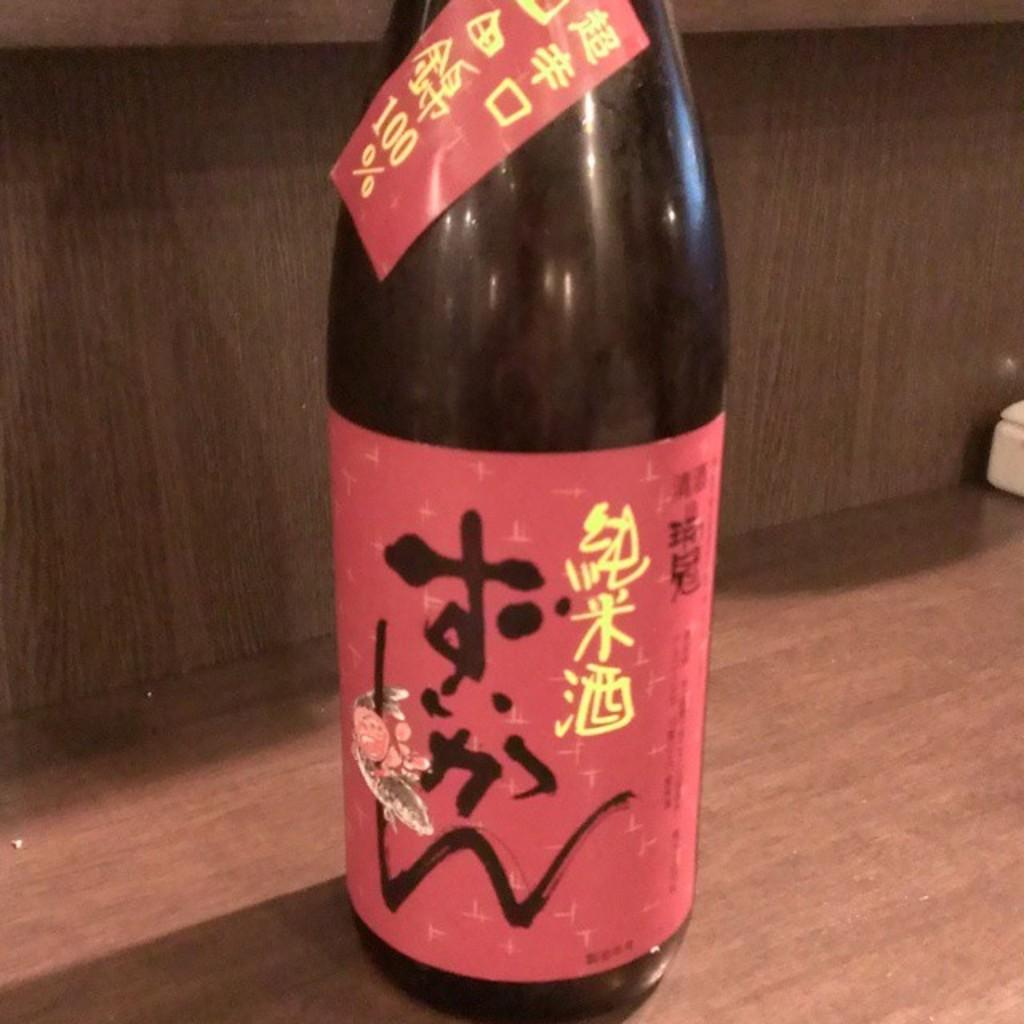<image>
Describe the image concisely. A bottle of beer has a sticker that says 100% 